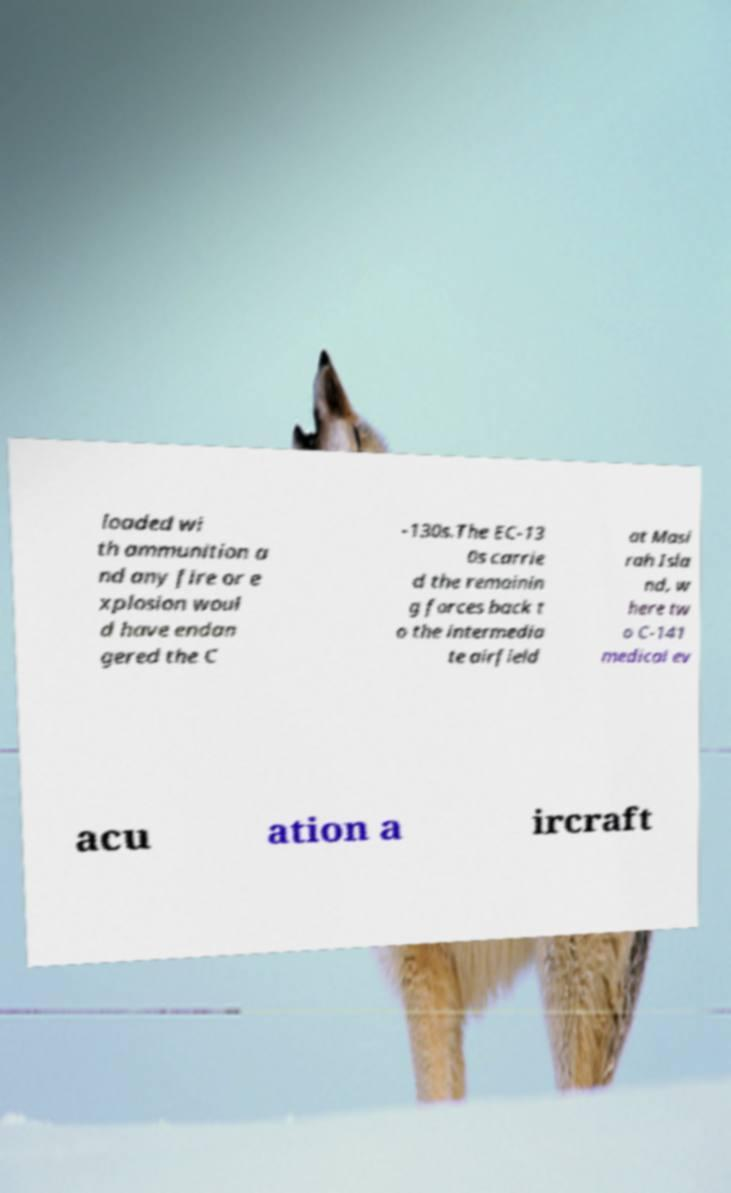Could you assist in decoding the text presented in this image and type it out clearly? loaded wi th ammunition a nd any fire or e xplosion woul d have endan gered the C -130s.The EC-13 0s carrie d the remainin g forces back t o the intermedia te airfield at Masi rah Isla nd, w here tw o C-141 medical ev acu ation a ircraft 